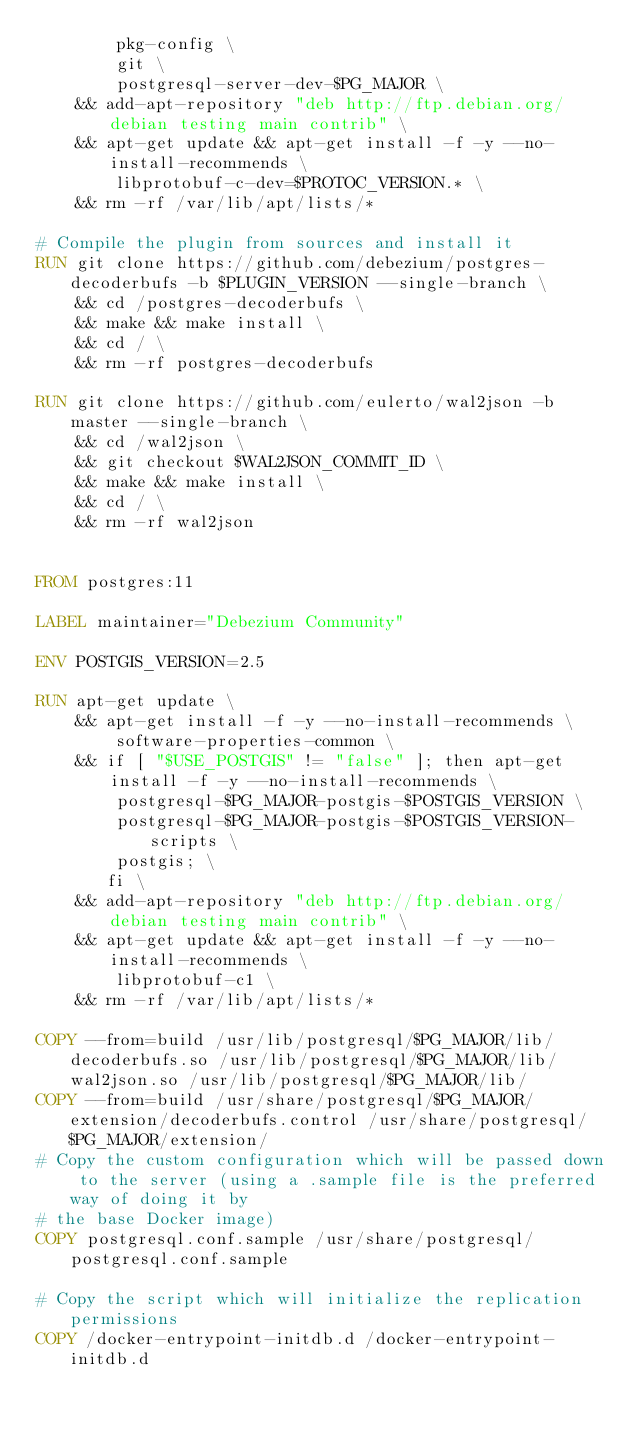<code> <loc_0><loc_0><loc_500><loc_500><_Dockerfile_>        pkg-config \
        git \
        postgresql-server-dev-$PG_MAJOR \
    && add-apt-repository "deb http://ftp.debian.org/debian testing main contrib" \
    && apt-get update && apt-get install -f -y --no-install-recommends \
        libprotobuf-c-dev=$PROTOC_VERSION.* \
    && rm -rf /var/lib/apt/lists/*

# Compile the plugin from sources and install it
RUN git clone https://github.com/debezium/postgres-decoderbufs -b $PLUGIN_VERSION --single-branch \
    && cd /postgres-decoderbufs \
    && make && make install \
    && cd / \
    && rm -rf postgres-decoderbufs

RUN git clone https://github.com/eulerto/wal2json -b master --single-branch \
    && cd /wal2json \
    && git checkout $WAL2JSON_COMMIT_ID \
    && make && make install \
    && cd / \
    && rm -rf wal2json


FROM postgres:11

LABEL maintainer="Debezium Community"

ENV POSTGIS_VERSION=2.5

RUN apt-get update \
    && apt-get install -f -y --no-install-recommends \
        software-properties-common \
    && if [ "$USE_POSTGIS" != "false" ]; then apt-get install -f -y --no-install-recommends \
        postgresql-$PG_MAJOR-postgis-$POSTGIS_VERSION \
        postgresql-$PG_MAJOR-postgis-$POSTGIS_VERSION-scripts \
        postgis; \
       fi \
    && add-apt-repository "deb http://ftp.debian.org/debian testing main contrib" \
    && apt-get update && apt-get install -f -y --no-install-recommends \
        libprotobuf-c1 \
    && rm -rf /var/lib/apt/lists/*

COPY --from=build /usr/lib/postgresql/$PG_MAJOR/lib/decoderbufs.so /usr/lib/postgresql/$PG_MAJOR/lib/wal2json.so /usr/lib/postgresql/$PG_MAJOR/lib/
COPY --from=build /usr/share/postgresql/$PG_MAJOR/extension/decoderbufs.control /usr/share/postgresql/$PG_MAJOR/extension/
# Copy the custom configuration which will be passed down to the server (using a .sample file is the preferred way of doing it by
# the base Docker image)
COPY postgresql.conf.sample /usr/share/postgresql/postgresql.conf.sample

# Copy the script which will initialize the replication permissions
COPY /docker-entrypoint-initdb.d /docker-entrypoint-initdb.d
</code> 